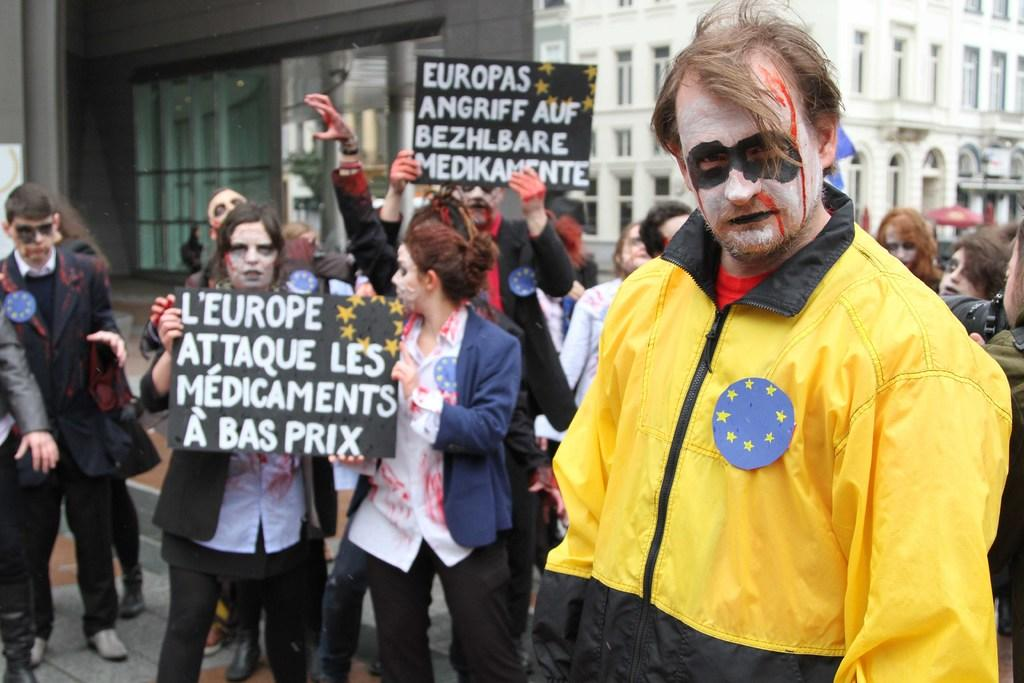Who is the main subject in the image? There is a man in the image. What is the man wearing? The man is wearing a yellow jacket. What can be seen in the background of the image? There are many people in the background of the image, and they are holding boards. What is at the bottom of the image? There is a road at the bottom of the image. What type of bridge can be seen in the image? There is no bridge present in the image. What effect does the man's yellow jacket have on the environment in the image? The man's yellow jacket does not have any effect on the environment in the image; it is simply a piece of clothing he is wearing. 